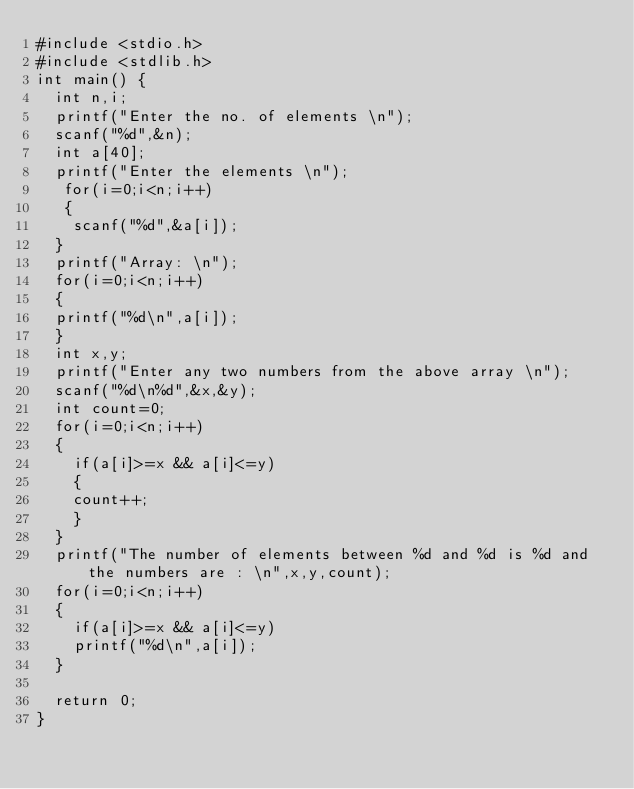<code> <loc_0><loc_0><loc_500><loc_500><_C_>#include <stdio.h>
#include <stdlib.h>
int main() {
	int n,i;
	printf("Enter the no. of elements \n");
	scanf("%d",&n);
	int a[40];
	printf("Enter the elements \n");
   for(i=0;i<n;i++)
   {
   	scanf("%d",&a[i]);
	}
	printf("Array: \n");
	for(i=0;i<n;i++)
	{
	printf("%d\n",a[i]);	
	}	
	int x,y;
	printf("Enter any two numbers from the above array \n");
	scanf("%d\n%d",&x,&y);
	int count=0;
	for(i=0;i<n;i++)
	{
		if(a[i]>=x && a[i]<=y)
		{
		count++;	
		}
	}
	printf("The number of elements between %d and %d is %d and the numbers are : \n",x,y,count);
	for(i=0;i<n;i++)
	{
		if(a[i]>=x && a[i]<=y)
		printf("%d\n",a[i]);
	}
	
	return 0;
}
</code> 